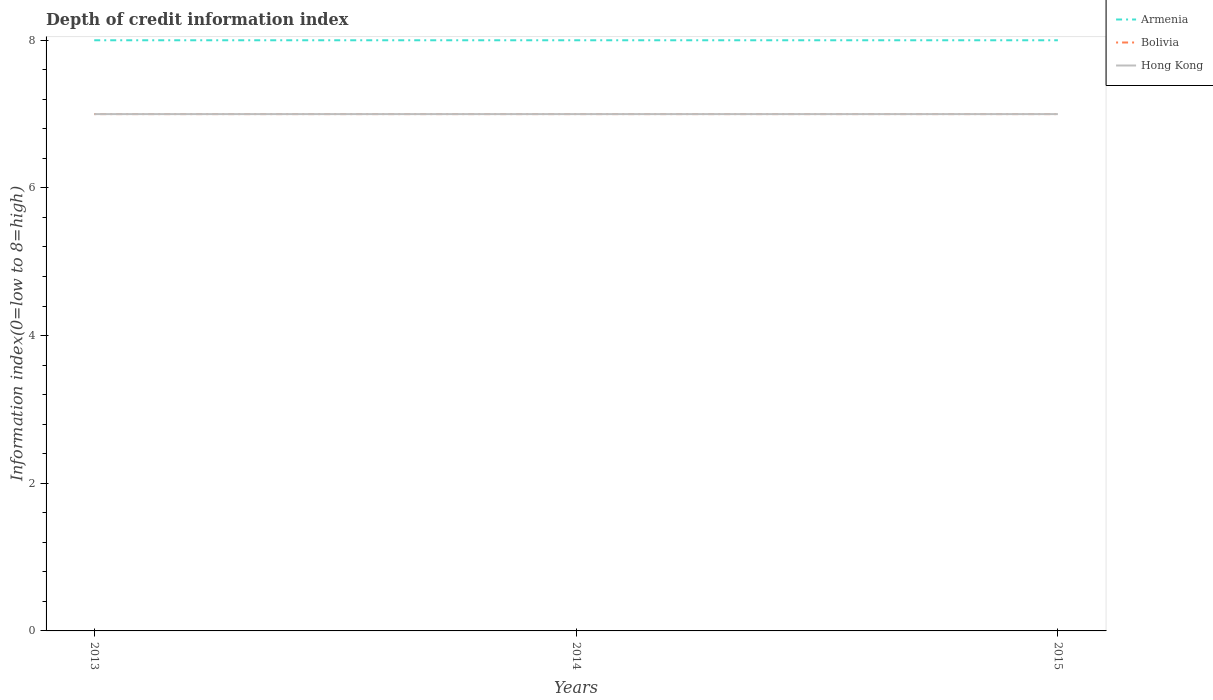Is the number of lines equal to the number of legend labels?
Offer a very short reply. Yes. Across all years, what is the maximum information index in Bolivia?
Your answer should be very brief. 7. What is the total information index in Armenia in the graph?
Offer a very short reply. 0. How many lines are there?
Your answer should be compact. 3. What is the difference between two consecutive major ticks on the Y-axis?
Ensure brevity in your answer.  2. Does the graph contain grids?
Ensure brevity in your answer.  No. Where does the legend appear in the graph?
Provide a short and direct response. Top right. How many legend labels are there?
Make the answer very short. 3. What is the title of the graph?
Your answer should be very brief. Depth of credit information index. Does "Chile" appear as one of the legend labels in the graph?
Give a very brief answer. No. What is the label or title of the Y-axis?
Your answer should be very brief. Information index(0=low to 8=high). What is the Information index(0=low to 8=high) in Bolivia in 2013?
Offer a terse response. 7. What is the Information index(0=low to 8=high) in Hong Kong in 2013?
Keep it short and to the point. 7. What is the Information index(0=low to 8=high) of Hong Kong in 2015?
Your answer should be very brief. 7. Across all years, what is the maximum Information index(0=low to 8=high) in Armenia?
Your answer should be very brief. 8. Across all years, what is the minimum Information index(0=low to 8=high) of Armenia?
Give a very brief answer. 8. Across all years, what is the minimum Information index(0=low to 8=high) of Bolivia?
Give a very brief answer. 7. What is the total Information index(0=low to 8=high) in Armenia in the graph?
Give a very brief answer. 24. What is the total Information index(0=low to 8=high) of Hong Kong in the graph?
Make the answer very short. 21. What is the difference between the Information index(0=low to 8=high) in Armenia in 2013 and that in 2014?
Make the answer very short. 0. What is the difference between the Information index(0=low to 8=high) in Bolivia in 2013 and that in 2014?
Ensure brevity in your answer.  0. What is the difference between the Information index(0=low to 8=high) of Armenia in 2013 and that in 2015?
Your answer should be compact. 0. What is the difference between the Information index(0=low to 8=high) in Bolivia in 2013 and that in 2015?
Your response must be concise. 0. What is the difference between the Information index(0=low to 8=high) of Hong Kong in 2013 and that in 2015?
Make the answer very short. 0. What is the difference between the Information index(0=low to 8=high) of Armenia in 2013 and the Information index(0=low to 8=high) of Bolivia in 2014?
Provide a succinct answer. 1. What is the difference between the Information index(0=low to 8=high) of Armenia in 2013 and the Information index(0=low to 8=high) of Hong Kong in 2014?
Offer a very short reply. 1. What is the difference between the Information index(0=low to 8=high) in Armenia in 2013 and the Information index(0=low to 8=high) in Bolivia in 2015?
Ensure brevity in your answer.  1. What is the difference between the Information index(0=low to 8=high) in Armenia in 2013 and the Information index(0=low to 8=high) in Hong Kong in 2015?
Provide a succinct answer. 1. What is the difference between the Information index(0=low to 8=high) of Bolivia in 2013 and the Information index(0=low to 8=high) of Hong Kong in 2015?
Offer a terse response. 0. What is the difference between the Information index(0=low to 8=high) in Armenia in 2014 and the Information index(0=low to 8=high) in Bolivia in 2015?
Offer a very short reply. 1. What is the difference between the Information index(0=low to 8=high) of Armenia in 2014 and the Information index(0=low to 8=high) of Hong Kong in 2015?
Offer a terse response. 1. What is the average Information index(0=low to 8=high) of Armenia per year?
Your answer should be compact. 8. What is the average Information index(0=low to 8=high) in Bolivia per year?
Provide a short and direct response. 7. What is the average Information index(0=low to 8=high) in Hong Kong per year?
Offer a terse response. 7. In the year 2014, what is the difference between the Information index(0=low to 8=high) in Armenia and Information index(0=low to 8=high) in Bolivia?
Your answer should be very brief. 1. In the year 2015, what is the difference between the Information index(0=low to 8=high) of Armenia and Information index(0=low to 8=high) of Bolivia?
Your answer should be very brief. 1. In the year 2015, what is the difference between the Information index(0=low to 8=high) of Armenia and Information index(0=low to 8=high) of Hong Kong?
Your answer should be very brief. 1. In the year 2015, what is the difference between the Information index(0=low to 8=high) of Bolivia and Information index(0=low to 8=high) of Hong Kong?
Make the answer very short. 0. What is the ratio of the Information index(0=low to 8=high) in Armenia in 2013 to that in 2014?
Ensure brevity in your answer.  1. What is the ratio of the Information index(0=low to 8=high) in Bolivia in 2013 to that in 2014?
Your answer should be compact. 1. What is the ratio of the Information index(0=low to 8=high) in Bolivia in 2013 to that in 2015?
Offer a very short reply. 1. What is the ratio of the Information index(0=low to 8=high) in Hong Kong in 2013 to that in 2015?
Give a very brief answer. 1. What is the difference between the highest and the second highest Information index(0=low to 8=high) in Bolivia?
Keep it short and to the point. 0. What is the difference between the highest and the lowest Information index(0=low to 8=high) in Armenia?
Make the answer very short. 0. What is the difference between the highest and the lowest Information index(0=low to 8=high) in Bolivia?
Your response must be concise. 0. What is the difference between the highest and the lowest Information index(0=low to 8=high) of Hong Kong?
Offer a terse response. 0. 